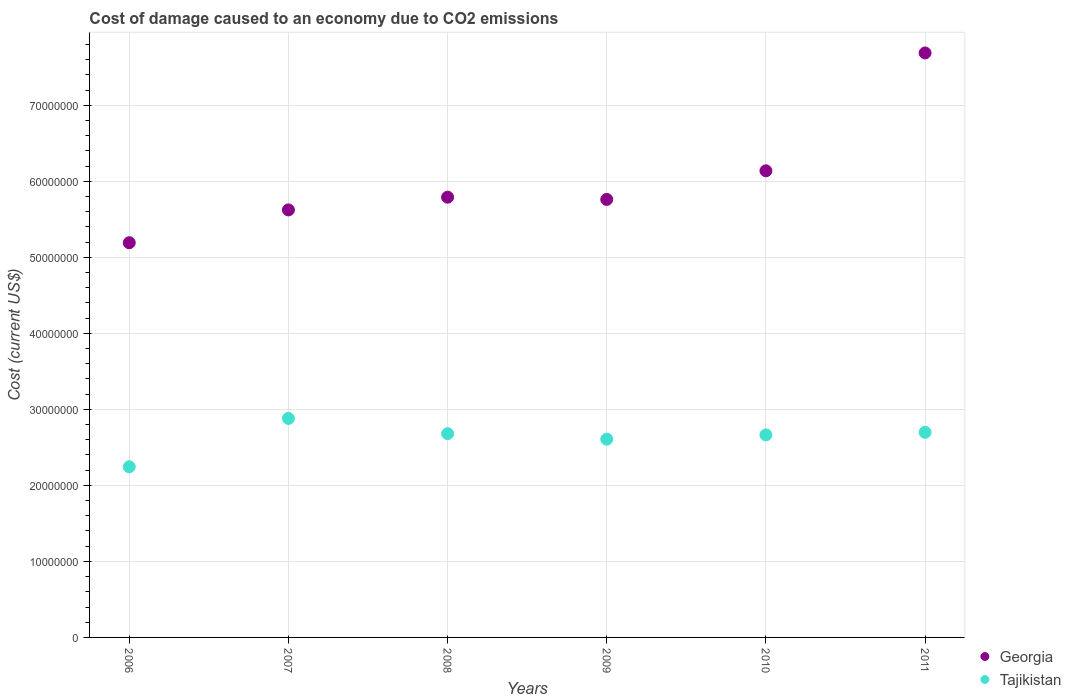What is the cost of damage caused due to CO2 emissisons in Georgia in 2007?
Provide a succinct answer. 5.62e+07. Across all years, what is the maximum cost of damage caused due to CO2 emissisons in Tajikistan?
Your answer should be very brief. 2.88e+07. Across all years, what is the minimum cost of damage caused due to CO2 emissisons in Tajikistan?
Keep it short and to the point. 2.24e+07. In which year was the cost of damage caused due to CO2 emissisons in Georgia maximum?
Give a very brief answer. 2011. What is the total cost of damage caused due to CO2 emissisons in Georgia in the graph?
Offer a terse response. 3.62e+08. What is the difference between the cost of damage caused due to CO2 emissisons in Georgia in 2007 and that in 2010?
Make the answer very short. -5.14e+06. What is the difference between the cost of damage caused due to CO2 emissisons in Georgia in 2010 and the cost of damage caused due to CO2 emissisons in Tajikistan in 2008?
Offer a very short reply. 3.46e+07. What is the average cost of damage caused due to CO2 emissisons in Georgia per year?
Your answer should be very brief. 6.03e+07. In the year 2008, what is the difference between the cost of damage caused due to CO2 emissisons in Tajikistan and cost of damage caused due to CO2 emissisons in Georgia?
Your answer should be very brief. -3.11e+07. What is the ratio of the cost of damage caused due to CO2 emissisons in Tajikistan in 2006 to that in 2010?
Your response must be concise. 0.84. What is the difference between the highest and the second highest cost of damage caused due to CO2 emissisons in Tajikistan?
Your answer should be compact. 1.83e+06. What is the difference between the highest and the lowest cost of damage caused due to CO2 emissisons in Georgia?
Make the answer very short. 2.50e+07. In how many years, is the cost of damage caused due to CO2 emissisons in Georgia greater than the average cost of damage caused due to CO2 emissisons in Georgia taken over all years?
Your answer should be very brief. 2. Is the sum of the cost of damage caused due to CO2 emissisons in Georgia in 2007 and 2010 greater than the maximum cost of damage caused due to CO2 emissisons in Tajikistan across all years?
Provide a succinct answer. Yes. Does the cost of damage caused due to CO2 emissisons in Georgia monotonically increase over the years?
Offer a very short reply. No. How many dotlines are there?
Your answer should be compact. 2. Are the values on the major ticks of Y-axis written in scientific E-notation?
Provide a succinct answer. No. Does the graph contain any zero values?
Provide a succinct answer. No. How many legend labels are there?
Your answer should be very brief. 2. What is the title of the graph?
Give a very brief answer. Cost of damage caused to an economy due to CO2 emissions. Does "High income: OECD" appear as one of the legend labels in the graph?
Offer a terse response. No. What is the label or title of the Y-axis?
Keep it short and to the point. Cost (current US$). What is the Cost (current US$) of Georgia in 2006?
Keep it short and to the point. 5.19e+07. What is the Cost (current US$) in Tajikistan in 2006?
Offer a terse response. 2.24e+07. What is the Cost (current US$) in Georgia in 2007?
Offer a terse response. 5.62e+07. What is the Cost (current US$) of Tajikistan in 2007?
Your response must be concise. 2.88e+07. What is the Cost (current US$) in Georgia in 2008?
Keep it short and to the point. 5.79e+07. What is the Cost (current US$) of Tajikistan in 2008?
Keep it short and to the point. 2.68e+07. What is the Cost (current US$) of Georgia in 2009?
Your answer should be very brief. 5.76e+07. What is the Cost (current US$) of Tajikistan in 2009?
Keep it short and to the point. 2.61e+07. What is the Cost (current US$) of Georgia in 2010?
Offer a very short reply. 6.14e+07. What is the Cost (current US$) in Tajikistan in 2010?
Keep it short and to the point. 2.66e+07. What is the Cost (current US$) of Georgia in 2011?
Give a very brief answer. 7.69e+07. What is the Cost (current US$) in Tajikistan in 2011?
Your response must be concise. 2.70e+07. Across all years, what is the maximum Cost (current US$) of Georgia?
Ensure brevity in your answer.  7.69e+07. Across all years, what is the maximum Cost (current US$) of Tajikistan?
Give a very brief answer. 2.88e+07. Across all years, what is the minimum Cost (current US$) of Georgia?
Offer a terse response. 5.19e+07. Across all years, what is the minimum Cost (current US$) in Tajikistan?
Your answer should be compact. 2.24e+07. What is the total Cost (current US$) in Georgia in the graph?
Offer a terse response. 3.62e+08. What is the total Cost (current US$) of Tajikistan in the graph?
Your answer should be very brief. 1.58e+08. What is the difference between the Cost (current US$) of Georgia in 2006 and that in 2007?
Your response must be concise. -4.32e+06. What is the difference between the Cost (current US$) in Tajikistan in 2006 and that in 2007?
Make the answer very short. -6.36e+06. What is the difference between the Cost (current US$) of Georgia in 2006 and that in 2008?
Provide a short and direct response. -5.99e+06. What is the difference between the Cost (current US$) of Tajikistan in 2006 and that in 2008?
Your answer should be compact. -4.36e+06. What is the difference between the Cost (current US$) of Georgia in 2006 and that in 2009?
Give a very brief answer. -5.70e+06. What is the difference between the Cost (current US$) of Tajikistan in 2006 and that in 2009?
Your answer should be very brief. -3.63e+06. What is the difference between the Cost (current US$) of Georgia in 2006 and that in 2010?
Ensure brevity in your answer.  -9.46e+06. What is the difference between the Cost (current US$) of Tajikistan in 2006 and that in 2010?
Give a very brief answer. -4.19e+06. What is the difference between the Cost (current US$) in Georgia in 2006 and that in 2011?
Your response must be concise. -2.50e+07. What is the difference between the Cost (current US$) in Tajikistan in 2006 and that in 2011?
Your answer should be very brief. -4.53e+06. What is the difference between the Cost (current US$) of Georgia in 2007 and that in 2008?
Provide a succinct answer. -1.67e+06. What is the difference between the Cost (current US$) of Tajikistan in 2007 and that in 2008?
Provide a succinct answer. 2.00e+06. What is the difference between the Cost (current US$) of Georgia in 2007 and that in 2009?
Offer a terse response. -1.38e+06. What is the difference between the Cost (current US$) in Tajikistan in 2007 and that in 2009?
Give a very brief answer. 2.73e+06. What is the difference between the Cost (current US$) in Georgia in 2007 and that in 2010?
Give a very brief answer. -5.14e+06. What is the difference between the Cost (current US$) of Tajikistan in 2007 and that in 2010?
Give a very brief answer. 2.17e+06. What is the difference between the Cost (current US$) in Georgia in 2007 and that in 2011?
Offer a very short reply. -2.06e+07. What is the difference between the Cost (current US$) in Tajikistan in 2007 and that in 2011?
Provide a short and direct response. 1.83e+06. What is the difference between the Cost (current US$) of Georgia in 2008 and that in 2009?
Offer a terse response. 2.94e+05. What is the difference between the Cost (current US$) of Tajikistan in 2008 and that in 2009?
Make the answer very short. 7.25e+05. What is the difference between the Cost (current US$) of Georgia in 2008 and that in 2010?
Keep it short and to the point. -3.47e+06. What is the difference between the Cost (current US$) in Tajikistan in 2008 and that in 2010?
Ensure brevity in your answer.  1.64e+05. What is the difference between the Cost (current US$) in Georgia in 2008 and that in 2011?
Make the answer very short. -1.90e+07. What is the difference between the Cost (current US$) of Tajikistan in 2008 and that in 2011?
Offer a very short reply. -1.74e+05. What is the difference between the Cost (current US$) in Georgia in 2009 and that in 2010?
Provide a short and direct response. -3.76e+06. What is the difference between the Cost (current US$) in Tajikistan in 2009 and that in 2010?
Provide a succinct answer. -5.62e+05. What is the difference between the Cost (current US$) of Georgia in 2009 and that in 2011?
Your response must be concise. -1.93e+07. What is the difference between the Cost (current US$) of Tajikistan in 2009 and that in 2011?
Offer a very short reply. -9.00e+05. What is the difference between the Cost (current US$) in Georgia in 2010 and that in 2011?
Provide a succinct answer. -1.55e+07. What is the difference between the Cost (current US$) of Tajikistan in 2010 and that in 2011?
Offer a very short reply. -3.38e+05. What is the difference between the Cost (current US$) in Georgia in 2006 and the Cost (current US$) in Tajikistan in 2007?
Your answer should be compact. 2.31e+07. What is the difference between the Cost (current US$) in Georgia in 2006 and the Cost (current US$) in Tajikistan in 2008?
Provide a short and direct response. 2.51e+07. What is the difference between the Cost (current US$) in Georgia in 2006 and the Cost (current US$) in Tajikistan in 2009?
Give a very brief answer. 2.58e+07. What is the difference between the Cost (current US$) in Georgia in 2006 and the Cost (current US$) in Tajikistan in 2010?
Provide a short and direct response. 2.53e+07. What is the difference between the Cost (current US$) in Georgia in 2006 and the Cost (current US$) in Tajikistan in 2011?
Your answer should be very brief. 2.49e+07. What is the difference between the Cost (current US$) of Georgia in 2007 and the Cost (current US$) of Tajikistan in 2008?
Provide a short and direct response. 2.94e+07. What is the difference between the Cost (current US$) of Georgia in 2007 and the Cost (current US$) of Tajikistan in 2009?
Make the answer very short. 3.02e+07. What is the difference between the Cost (current US$) of Georgia in 2007 and the Cost (current US$) of Tajikistan in 2010?
Ensure brevity in your answer.  2.96e+07. What is the difference between the Cost (current US$) in Georgia in 2007 and the Cost (current US$) in Tajikistan in 2011?
Offer a terse response. 2.93e+07. What is the difference between the Cost (current US$) in Georgia in 2008 and the Cost (current US$) in Tajikistan in 2009?
Give a very brief answer. 3.18e+07. What is the difference between the Cost (current US$) of Georgia in 2008 and the Cost (current US$) of Tajikistan in 2010?
Your answer should be compact. 3.13e+07. What is the difference between the Cost (current US$) of Georgia in 2008 and the Cost (current US$) of Tajikistan in 2011?
Offer a terse response. 3.09e+07. What is the difference between the Cost (current US$) in Georgia in 2009 and the Cost (current US$) in Tajikistan in 2010?
Provide a short and direct response. 3.10e+07. What is the difference between the Cost (current US$) in Georgia in 2009 and the Cost (current US$) in Tajikistan in 2011?
Provide a succinct answer. 3.06e+07. What is the difference between the Cost (current US$) in Georgia in 2010 and the Cost (current US$) in Tajikistan in 2011?
Make the answer very short. 3.44e+07. What is the average Cost (current US$) in Georgia per year?
Provide a succinct answer. 6.03e+07. What is the average Cost (current US$) of Tajikistan per year?
Give a very brief answer. 2.63e+07. In the year 2006, what is the difference between the Cost (current US$) in Georgia and Cost (current US$) in Tajikistan?
Your answer should be compact. 2.95e+07. In the year 2007, what is the difference between the Cost (current US$) in Georgia and Cost (current US$) in Tajikistan?
Offer a terse response. 2.74e+07. In the year 2008, what is the difference between the Cost (current US$) of Georgia and Cost (current US$) of Tajikistan?
Offer a very short reply. 3.11e+07. In the year 2009, what is the difference between the Cost (current US$) of Georgia and Cost (current US$) of Tajikistan?
Offer a very short reply. 3.15e+07. In the year 2010, what is the difference between the Cost (current US$) of Georgia and Cost (current US$) of Tajikistan?
Make the answer very short. 3.47e+07. In the year 2011, what is the difference between the Cost (current US$) of Georgia and Cost (current US$) of Tajikistan?
Your answer should be very brief. 4.99e+07. What is the ratio of the Cost (current US$) in Georgia in 2006 to that in 2007?
Offer a very short reply. 0.92. What is the ratio of the Cost (current US$) in Tajikistan in 2006 to that in 2007?
Your answer should be very brief. 0.78. What is the ratio of the Cost (current US$) in Georgia in 2006 to that in 2008?
Offer a terse response. 0.9. What is the ratio of the Cost (current US$) of Tajikistan in 2006 to that in 2008?
Your response must be concise. 0.84. What is the ratio of the Cost (current US$) of Georgia in 2006 to that in 2009?
Your response must be concise. 0.9. What is the ratio of the Cost (current US$) of Tajikistan in 2006 to that in 2009?
Keep it short and to the point. 0.86. What is the ratio of the Cost (current US$) of Georgia in 2006 to that in 2010?
Offer a very short reply. 0.85. What is the ratio of the Cost (current US$) in Tajikistan in 2006 to that in 2010?
Keep it short and to the point. 0.84. What is the ratio of the Cost (current US$) of Georgia in 2006 to that in 2011?
Offer a terse response. 0.68. What is the ratio of the Cost (current US$) of Tajikistan in 2006 to that in 2011?
Offer a terse response. 0.83. What is the ratio of the Cost (current US$) in Georgia in 2007 to that in 2008?
Your response must be concise. 0.97. What is the ratio of the Cost (current US$) of Tajikistan in 2007 to that in 2008?
Provide a short and direct response. 1.07. What is the ratio of the Cost (current US$) of Georgia in 2007 to that in 2009?
Give a very brief answer. 0.98. What is the ratio of the Cost (current US$) of Tajikistan in 2007 to that in 2009?
Offer a very short reply. 1.1. What is the ratio of the Cost (current US$) in Georgia in 2007 to that in 2010?
Keep it short and to the point. 0.92. What is the ratio of the Cost (current US$) in Tajikistan in 2007 to that in 2010?
Offer a terse response. 1.08. What is the ratio of the Cost (current US$) of Georgia in 2007 to that in 2011?
Offer a very short reply. 0.73. What is the ratio of the Cost (current US$) of Tajikistan in 2007 to that in 2011?
Keep it short and to the point. 1.07. What is the ratio of the Cost (current US$) of Tajikistan in 2008 to that in 2009?
Offer a very short reply. 1.03. What is the ratio of the Cost (current US$) in Georgia in 2008 to that in 2010?
Keep it short and to the point. 0.94. What is the ratio of the Cost (current US$) of Tajikistan in 2008 to that in 2010?
Ensure brevity in your answer.  1.01. What is the ratio of the Cost (current US$) in Georgia in 2008 to that in 2011?
Your answer should be compact. 0.75. What is the ratio of the Cost (current US$) in Tajikistan in 2008 to that in 2011?
Provide a succinct answer. 0.99. What is the ratio of the Cost (current US$) of Georgia in 2009 to that in 2010?
Give a very brief answer. 0.94. What is the ratio of the Cost (current US$) of Tajikistan in 2009 to that in 2010?
Your answer should be very brief. 0.98. What is the ratio of the Cost (current US$) of Georgia in 2009 to that in 2011?
Make the answer very short. 0.75. What is the ratio of the Cost (current US$) in Tajikistan in 2009 to that in 2011?
Keep it short and to the point. 0.97. What is the ratio of the Cost (current US$) in Georgia in 2010 to that in 2011?
Your answer should be compact. 0.8. What is the ratio of the Cost (current US$) in Tajikistan in 2010 to that in 2011?
Provide a short and direct response. 0.99. What is the difference between the highest and the second highest Cost (current US$) of Georgia?
Offer a terse response. 1.55e+07. What is the difference between the highest and the second highest Cost (current US$) of Tajikistan?
Ensure brevity in your answer.  1.83e+06. What is the difference between the highest and the lowest Cost (current US$) in Georgia?
Make the answer very short. 2.50e+07. What is the difference between the highest and the lowest Cost (current US$) of Tajikistan?
Offer a very short reply. 6.36e+06. 